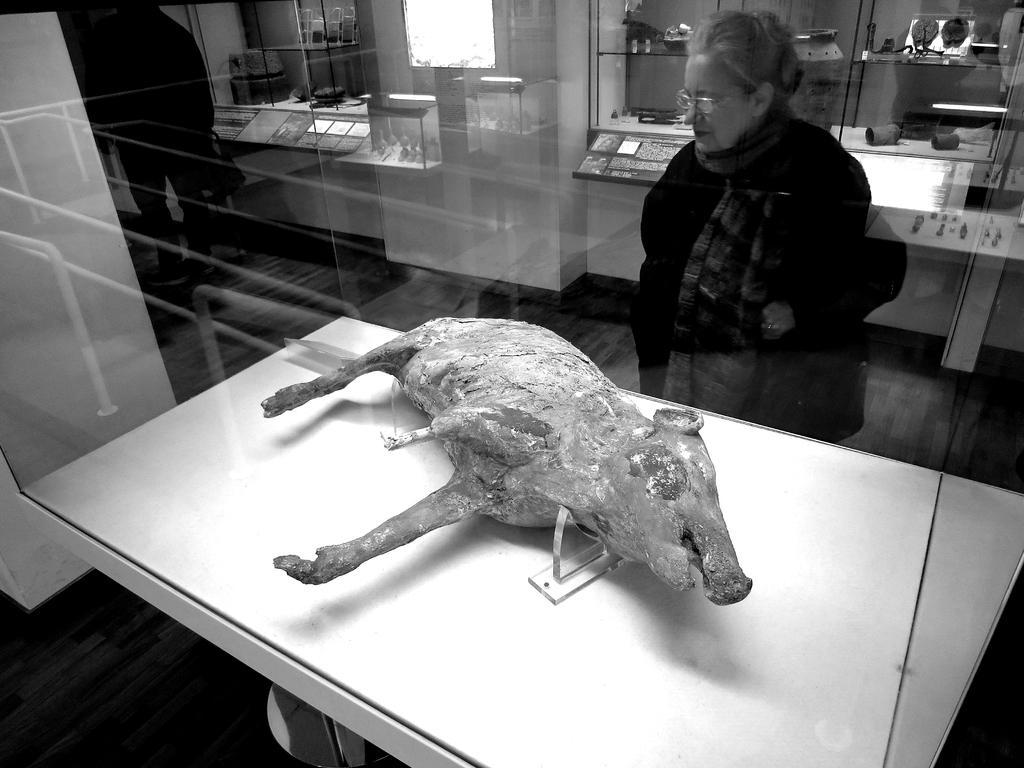Please provide a concise description of this image. In this image there is a woman standing, there is a man standing, there is a table towards the bottom of the image, there is an animal on the table, there is the wall, there are shelves, there are objects on the shelves, there is a light towards the top of the image, there is a pillar towards the left of the image. 